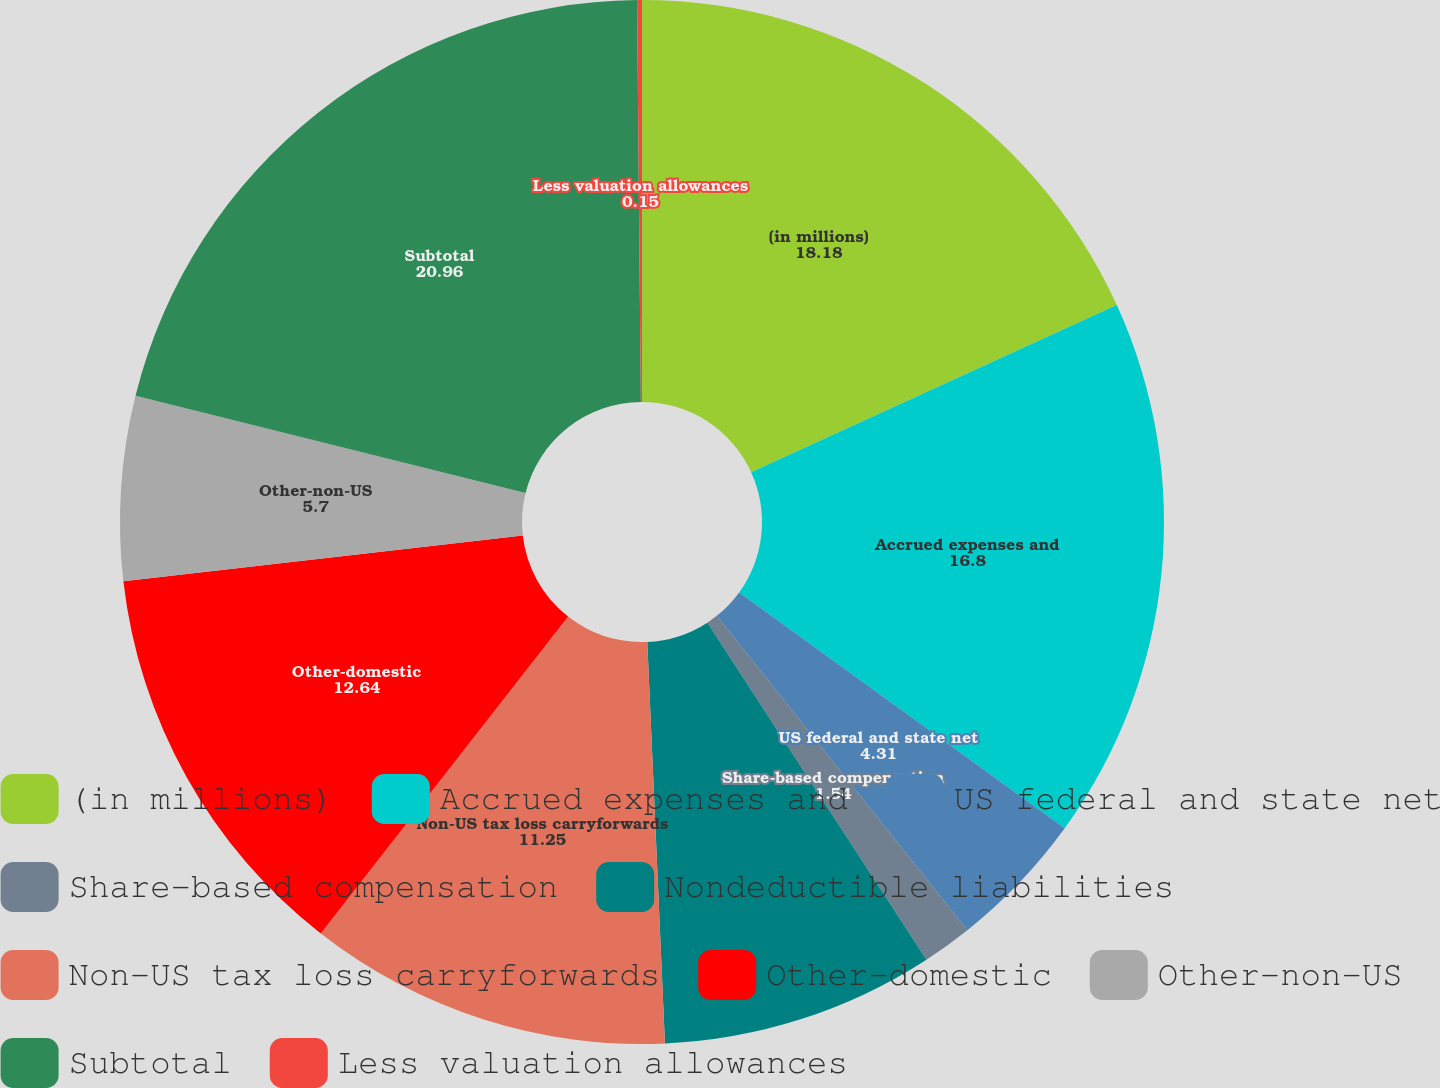<chart> <loc_0><loc_0><loc_500><loc_500><pie_chart><fcel>(in millions)<fcel>Accrued expenses and<fcel>US federal and state net<fcel>Share-based compensation<fcel>Nondeductible liabilities<fcel>Non-US tax loss carryforwards<fcel>Other-domestic<fcel>Other-non-US<fcel>Subtotal<fcel>Less valuation allowances<nl><fcel>18.18%<fcel>16.8%<fcel>4.31%<fcel>1.54%<fcel>8.47%<fcel>11.25%<fcel>12.64%<fcel>5.7%<fcel>20.96%<fcel>0.15%<nl></chart> 